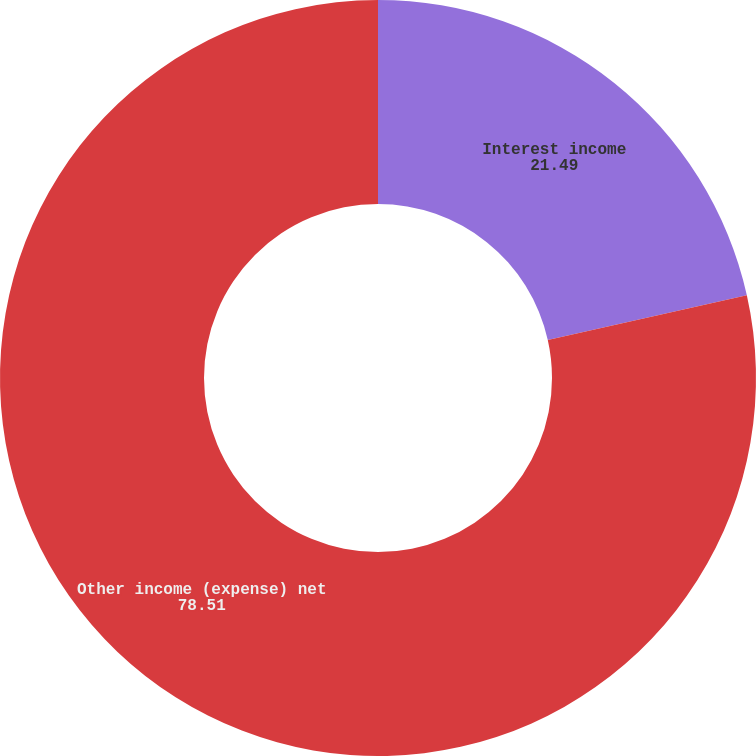Convert chart. <chart><loc_0><loc_0><loc_500><loc_500><pie_chart><fcel>Interest income<fcel>Other income (expense) net<nl><fcel>21.49%<fcel>78.51%<nl></chart> 